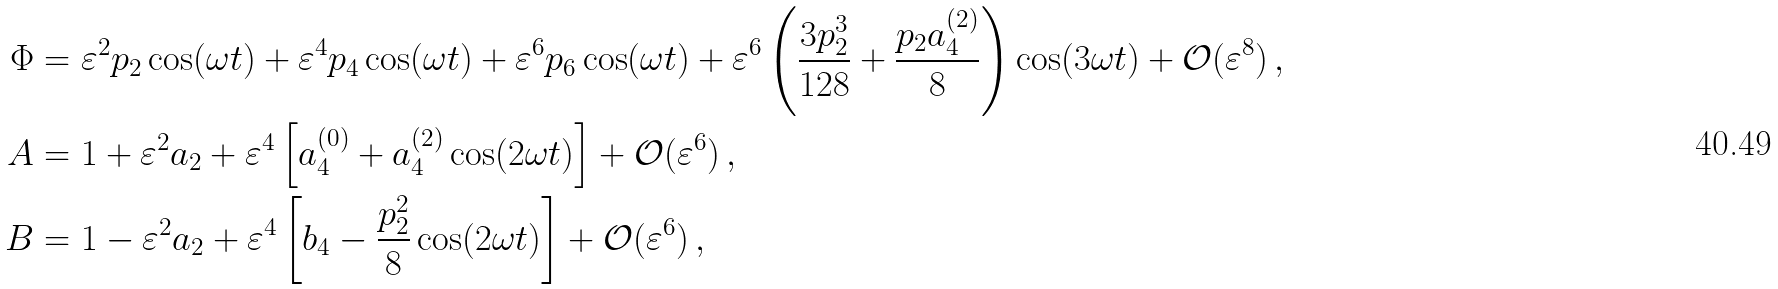<formula> <loc_0><loc_0><loc_500><loc_500>\Phi & = \varepsilon ^ { 2 } p _ { 2 } \cos ( \omega t ) + \varepsilon ^ { 4 } p _ { 4 } \cos ( \omega t ) + \varepsilon ^ { 6 } p _ { 6 } \cos ( \omega t ) + \varepsilon ^ { 6 } \left ( \frac { 3 p _ { 2 } ^ { 3 } } { 1 2 8 } + \frac { p _ { 2 } a _ { 4 } ^ { ( 2 ) } } { 8 } \right ) \cos ( 3 \omega t ) + \mathcal { O } ( \varepsilon ^ { 8 } ) \, , \\ A & = 1 + \varepsilon ^ { 2 } a _ { 2 } + \varepsilon ^ { 4 } \left [ a _ { 4 } ^ { ( 0 ) } + a _ { 4 } ^ { ( 2 ) } \cos ( 2 \omega t ) \right ] + \mathcal { O } ( \varepsilon ^ { 6 } ) \, , \\ B & = 1 - \varepsilon ^ { 2 } a _ { 2 } + \varepsilon ^ { 4 } \left [ b _ { 4 } - \frac { p _ { 2 } ^ { 2 } } { 8 } \cos ( 2 \omega t ) \right ] + \mathcal { O } ( \varepsilon ^ { 6 } ) \, ,</formula> 